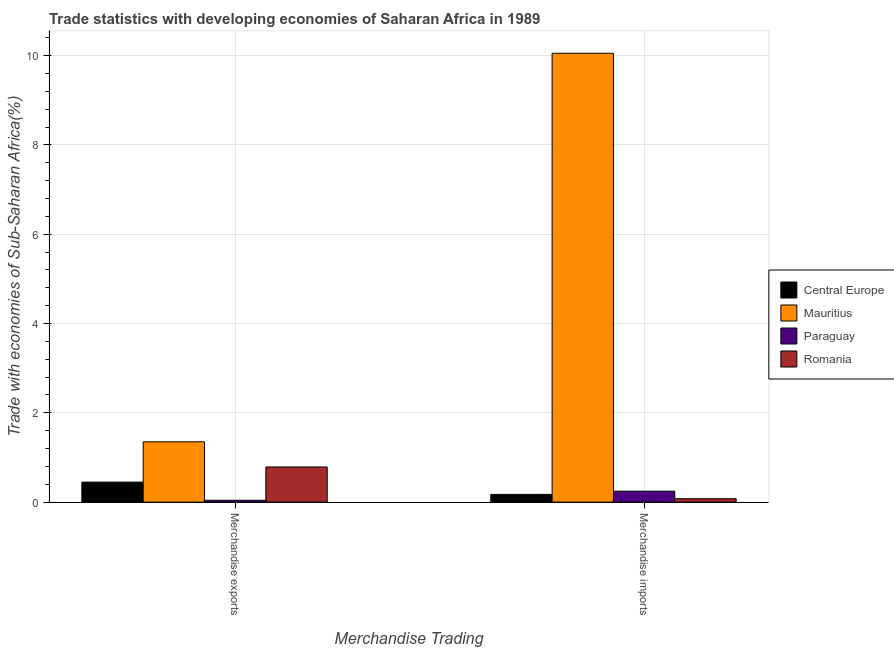How many groups of bars are there?
Make the answer very short. 2. How many bars are there on the 2nd tick from the left?
Make the answer very short. 4. What is the label of the 1st group of bars from the left?
Your answer should be very brief. Merchandise exports. What is the merchandise imports in Paraguay?
Offer a terse response. 0.24. Across all countries, what is the maximum merchandise imports?
Your response must be concise. 10.05. Across all countries, what is the minimum merchandise imports?
Offer a very short reply. 0.08. In which country was the merchandise exports maximum?
Give a very brief answer. Mauritius. In which country was the merchandise exports minimum?
Offer a very short reply. Paraguay. What is the total merchandise imports in the graph?
Ensure brevity in your answer.  10.55. What is the difference between the merchandise imports in Mauritius and that in Paraguay?
Give a very brief answer. 9.81. What is the difference between the merchandise exports in Romania and the merchandise imports in Central Europe?
Offer a very short reply. 0.61. What is the average merchandise exports per country?
Keep it short and to the point. 0.66. What is the difference between the merchandise imports and merchandise exports in Mauritius?
Offer a very short reply. 8.7. In how many countries, is the merchandise imports greater than 2.4 %?
Your response must be concise. 1. What is the ratio of the merchandise exports in Central Europe to that in Mauritius?
Provide a short and direct response. 0.33. What does the 4th bar from the left in Merchandise exports represents?
Offer a very short reply. Romania. What does the 4th bar from the right in Merchandise imports represents?
Offer a terse response. Central Europe. How many countries are there in the graph?
Your answer should be compact. 4. Are the values on the major ticks of Y-axis written in scientific E-notation?
Your answer should be compact. No. Does the graph contain any zero values?
Give a very brief answer. No. Where does the legend appear in the graph?
Your response must be concise. Center right. How are the legend labels stacked?
Your answer should be compact. Vertical. What is the title of the graph?
Your answer should be compact. Trade statistics with developing economies of Saharan Africa in 1989. What is the label or title of the X-axis?
Your answer should be compact. Merchandise Trading. What is the label or title of the Y-axis?
Offer a terse response. Trade with economies of Sub-Saharan Africa(%). What is the Trade with economies of Sub-Saharan Africa(%) in Central Europe in Merchandise exports?
Provide a short and direct response. 0.45. What is the Trade with economies of Sub-Saharan Africa(%) in Mauritius in Merchandise exports?
Give a very brief answer. 1.35. What is the Trade with economies of Sub-Saharan Africa(%) in Paraguay in Merchandise exports?
Your answer should be compact. 0.04. What is the Trade with economies of Sub-Saharan Africa(%) in Romania in Merchandise exports?
Provide a succinct answer. 0.79. What is the Trade with economies of Sub-Saharan Africa(%) of Central Europe in Merchandise imports?
Your response must be concise. 0.17. What is the Trade with economies of Sub-Saharan Africa(%) of Mauritius in Merchandise imports?
Give a very brief answer. 10.05. What is the Trade with economies of Sub-Saharan Africa(%) in Paraguay in Merchandise imports?
Your response must be concise. 0.24. What is the Trade with economies of Sub-Saharan Africa(%) in Romania in Merchandise imports?
Provide a succinct answer. 0.08. Across all Merchandise Trading, what is the maximum Trade with economies of Sub-Saharan Africa(%) in Central Europe?
Your answer should be very brief. 0.45. Across all Merchandise Trading, what is the maximum Trade with economies of Sub-Saharan Africa(%) of Mauritius?
Provide a short and direct response. 10.05. Across all Merchandise Trading, what is the maximum Trade with economies of Sub-Saharan Africa(%) in Paraguay?
Offer a terse response. 0.24. Across all Merchandise Trading, what is the maximum Trade with economies of Sub-Saharan Africa(%) of Romania?
Ensure brevity in your answer.  0.79. Across all Merchandise Trading, what is the minimum Trade with economies of Sub-Saharan Africa(%) of Central Europe?
Provide a succinct answer. 0.17. Across all Merchandise Trading, what is the minimum Trade with economies of Sub-Saharan Africa(%) in Mauritius?
Offer a terse response. 1.35. Across all Merchandise Trading, what is the minimum Trade with economies of Sub-Saharan Africa(%) in Paraguay?
Provide a short and direct response. 0.04. Across all Merchandise Trading, what is the minimum Trade with economies of Sub-Saharan Africa(%) of Romania?
Provide a succinct answer. 0.08. What is the total Trade with economies of Sub-Saharan Africa(%) in Central Europe in the graph?
Keep it short and to the point. 0.62. What is the total Trade with economies of Sub-Saharan Africa(%) in Mauritius in the graph?
Provide a succinct answer. 11.4. What is the total Trade with economies of Sub-Saharan Africa(%) of Paraguay in the graph?
Ensure brevity in your answer.  0.29. What is the total Trade with economies of Sub-Saharan Africa(%) in Romania in the graph?
Provide a short and direct response. 0.86. What is the difference between the Trade with economies of Sub-Saharan Africa(%) in Central Europe in Merchandise exports and that in Merchandise imports?
Offer a very short reply. 0.27. What is the difference between the Trade with economies of Sub-Saharan Africa(%) of Mauritius in Merchandise exports and that in Merchandise imports?
Provide a short and direct response. -8.7. What is the difference between the Trade with economies of Sub-Saharan Africa(%) of Paraguay in Merchandise exports and that in Merchandise imports?
Your answer should be very brief. -0.2. What is the difference between the Trade with economies of Sub-Saharan Africa(%) in Romania in Merchandise exports and that in Merchandise imports?
Make the answer very short. 0.71. What is the difference between the Trade with economies of Sub-Saharan Africa(%) of Central Europe in Merchandise exports and the Trade with economies of Sub-Saharan Africa(%) of Mauritius in Merchandise imports?
Provide a succinct answer. -9.6. What is the difference between the Trade with economies of Sub-Saharan Africa(%) in Central Europe in Merchandise exports and the Trade with economies of Sub-Saharan Africa(%) in Paraguay in Merchandise imports?
Keep it short and to the point. 0.2. What is the difference between the Trade with economies of Sub-Saharan Africa(%) of Central Europe in Merchandise exports and the Trade with economies of Sub-Saharan Africa(%) of Romania in Merchandise imports?
Give a very brief answer. 0.37. What is the difference between the Trade with economies of Sub-Saharan Africa(%) in Mauritius in Merchandise exports and the Trade with economies of Sub-Saharan Africa(%) in Paraguay in Merchandise imports?
Offer a very short reply. 1.11. What is the difference between the Trade with economies of Sub-Saharan Africa(%) of Mauritius in Merchandise exports and the Trade with economies of Sub-Saharan Africa(%) of Romania in Merchandise imports?
Ensure brevity in your answer.  1.27. What is the difference between the Trade with economies of Sub-Saharan Africa(%) of Paraguay in Merchandise exports and the Trade with economies of Sub-Saharan Africa(%) of Romania in Merchandise imports?
Your response must be concise. -0.04. What is the average Trade with economies of Sub-Saharan Africa(%) in Central Europe per Merchandise Trading?
Provide a short and direct response. 0.31. What is the average Trade with economies of Sub-Saharan Africa(%) in Mauritius per Merchandise Trading?
Give a very brief answer. 5.7. What is the average Trade with economies of Sub-Saharan Africa(%) of Paraguay per Merchandise Trading?
Give a very brief answer. 0.14. What is the average Trade with economies of Sub-Saharan Africa(%) in Romania per Merchandise Trading?
Provide a short and direct response. 0.43. What is the difference between the Trade with economies of Sub-Saharan Africa(%) in Central Europe and Trade with economies of Sub-Saharan Africa(%) in Mauritius in Merchandise exports?
Offer a very short reply. -0.9. What is the difference between the Trade with economies of Sub-Saharan Africa(%) in Central Europe and Trade with economies of Sub-Saharan Africa(%) in Paraguay in Merchandise exports?
Offer a terse response. 0.41. What is the difference between the Trade with economies of Sub-Saharan Africa(%) in Central Europe and Trade with economies of Sub-Saharan Africa(%) in Romania in Merchandise exports?
Offer a very short reply. -0.34. What is the difference between the Trade with economies of Sub-Saharan Africa(%) of Mauritius and Trade with economies of Sub-Saharan Africa(%) of Paraguay in Merchandise exports?
Give a very brief answer. 1.31. What is the difference between the Trade with economies of Sub-Saharan Africa(%) of Mauritius and Trade with economies of Sub-Saharan Africa(%) of Romania in Merchandise exports?
Make the answer very short. 0.56. What is the difference between the Trade with economies of Sub-Saharan Africa(%) in Paraguay and Trade with economies of Sub-Saharan Africa(%) in Romania in Merchandise exports?
Your answer should be very brief. -0.75. What is the difference between the Trade with economies of Sub-Saharan Africa(%) of Central Europe and Trade with economies of Sub-Saharan Africa(%) of Mauritius in Merchandise imports?
Your answer should be very brief. -9.88. What is the difference between the Trade with economies of Sub-Saharan Africa(%) of Central Europe and Trade with economies of Sub-Saharan Africa(%) of Paraguay in Merchandise imports?
Provide a succinct answer. -0.07. What is the difference between the Trade with economies of Sub-Saharan Africa(%) of Central Europe and Trade with economies of Sub-Saharan Africa(%) of Romania in Merchandise imports?
Offer a terse response. 0.1. What is the difference between the Trade with economies of Sub-Saharan Africa(%) of Mauritius and Trade with economies of Sub-Saharan Africa(%) of Paraguay in Merchandise imports?
Keep it short and to the point. 9.81. What is the difference between the Trade with economies of Sub-Saharan Africa(%) of Mauritius and Trade with economies of Sub-Saharan Africa(%) of Romania in Merchandise imports?
Make the answer very short. 9.98. What is the difference between the Trade with economies of Sub-Saharan Africa(%) of Paraguay and Trade with economies of Sub-Saharan Africa(%) of Romania in Merchandise imports?
Keep it short and to the point. 0.17. What is the ratio of the Trade with economies of Sub-Saharan Africa(%) of Central Europe in Merchandise exports to that in Merchandise imports?
Your answer should be compact. 2.59. What is the ratio of the Trade with economies of Sub-Saharan Africa(%) in Mauritius in Merchandise exports to that in Merchandise imports?
Offer a very short reply. 0.13. What is the ratio of the Trade with economies of Sub-Saharan Africa(%) in Paraguay in Merchandise exports to that in Merchandise imports?
Give a very brief answer. 0.17. What is the ratio of the Trade with economies of Sub-Saharan Africa(%) of Romania in Merchandise exports to that in Merchandise imports?
Offer a very short reply. 10.27. What is the difference between the highest and the second highest Trade with economies of Sub-Saharan Africa(%) of Central Europe?
Provide a succinct answer. 0.27. What is the difference between the highest and the second highest Trade with economies of Sub-Saharan Africa(%) of Mauritius?
Offer a terse response. 8.7. What is the difference between the highest and the second highest Trade with economies of Sub-Saharan Africa(%) in Paraguay?
Your answer should be very brief. 0.2. What is the difference between the highest and the second highest Trade with economies of Sub-Saharan Africa(%) in Romania?
Offer a very short reply. 0.71. What is the difference between the highest and the lowest Trade with economies of Sub-Saharan Africa(%) in Central Europe?
Offer a terse response. 0.27. What is the difference between the highest and the lowest Trade with economies of Sub-Saharan Africa(%) in Mauritius?
Offer a terse response. 8.7. What is the difference between the highest and the lowest Trade with economies of Sub-Saharan Africa(%) in Paraguay?
Give a very brief answer. 0.2. What is the difference between the highest and the lowest Trade with economies of Sub-Saharan Africa(%) of Romania?
Keep it short and to the point. 0.71. 